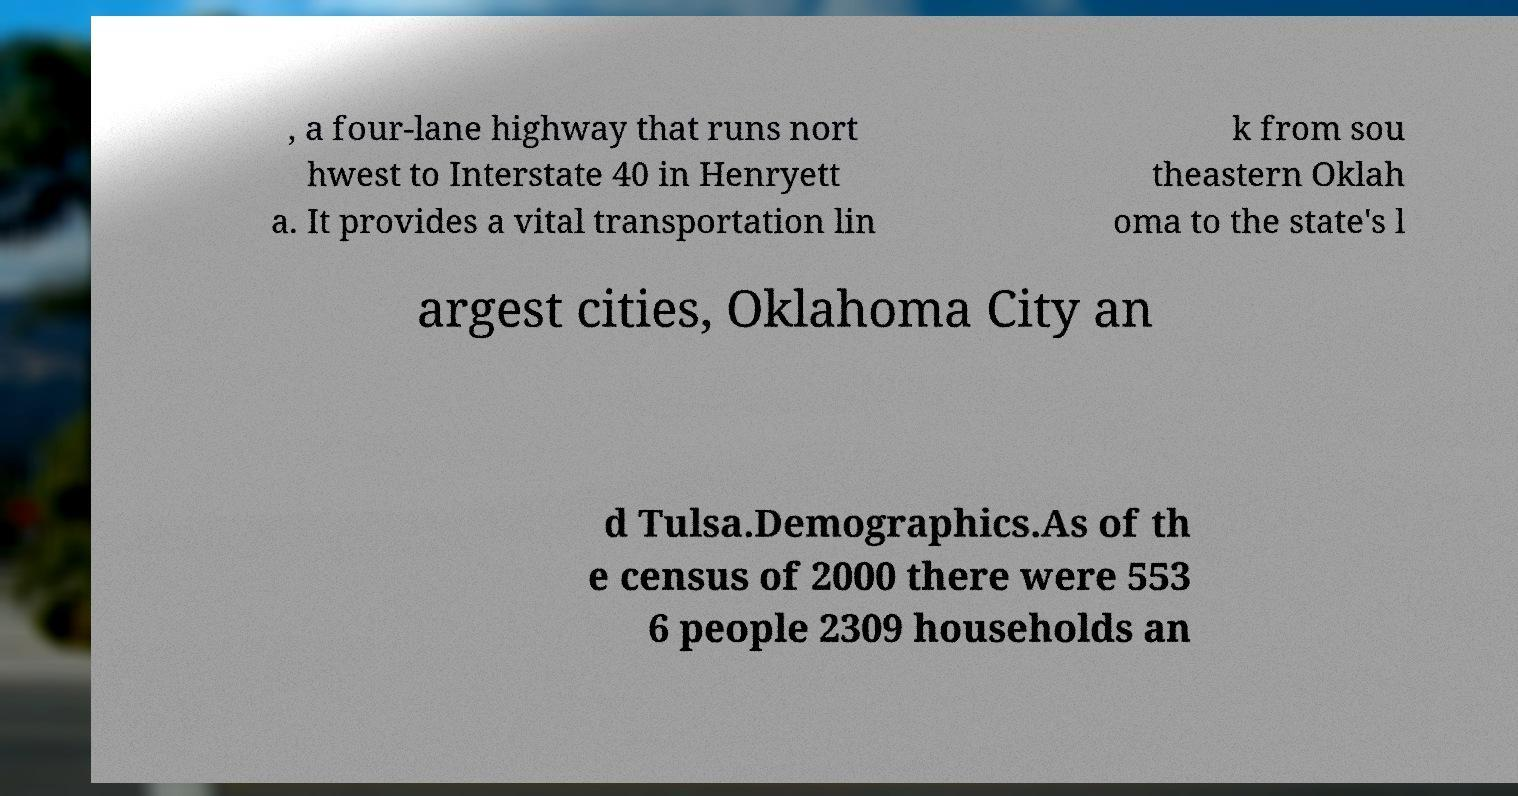Can you read and provide the text displayed in the image?This photo seems to have some interesting text. Can you extract and type it out for me? , a four-lane highway that runs nort hwest to Interstate 40 in Henryett a. It provides a vital transportation lin k from sou theastern Oklah oma to the state's l argest cities, Oklahoma City an d Tulsa.Demographics.As of th e census of 2000 there were 553 6 people 2309 households an 